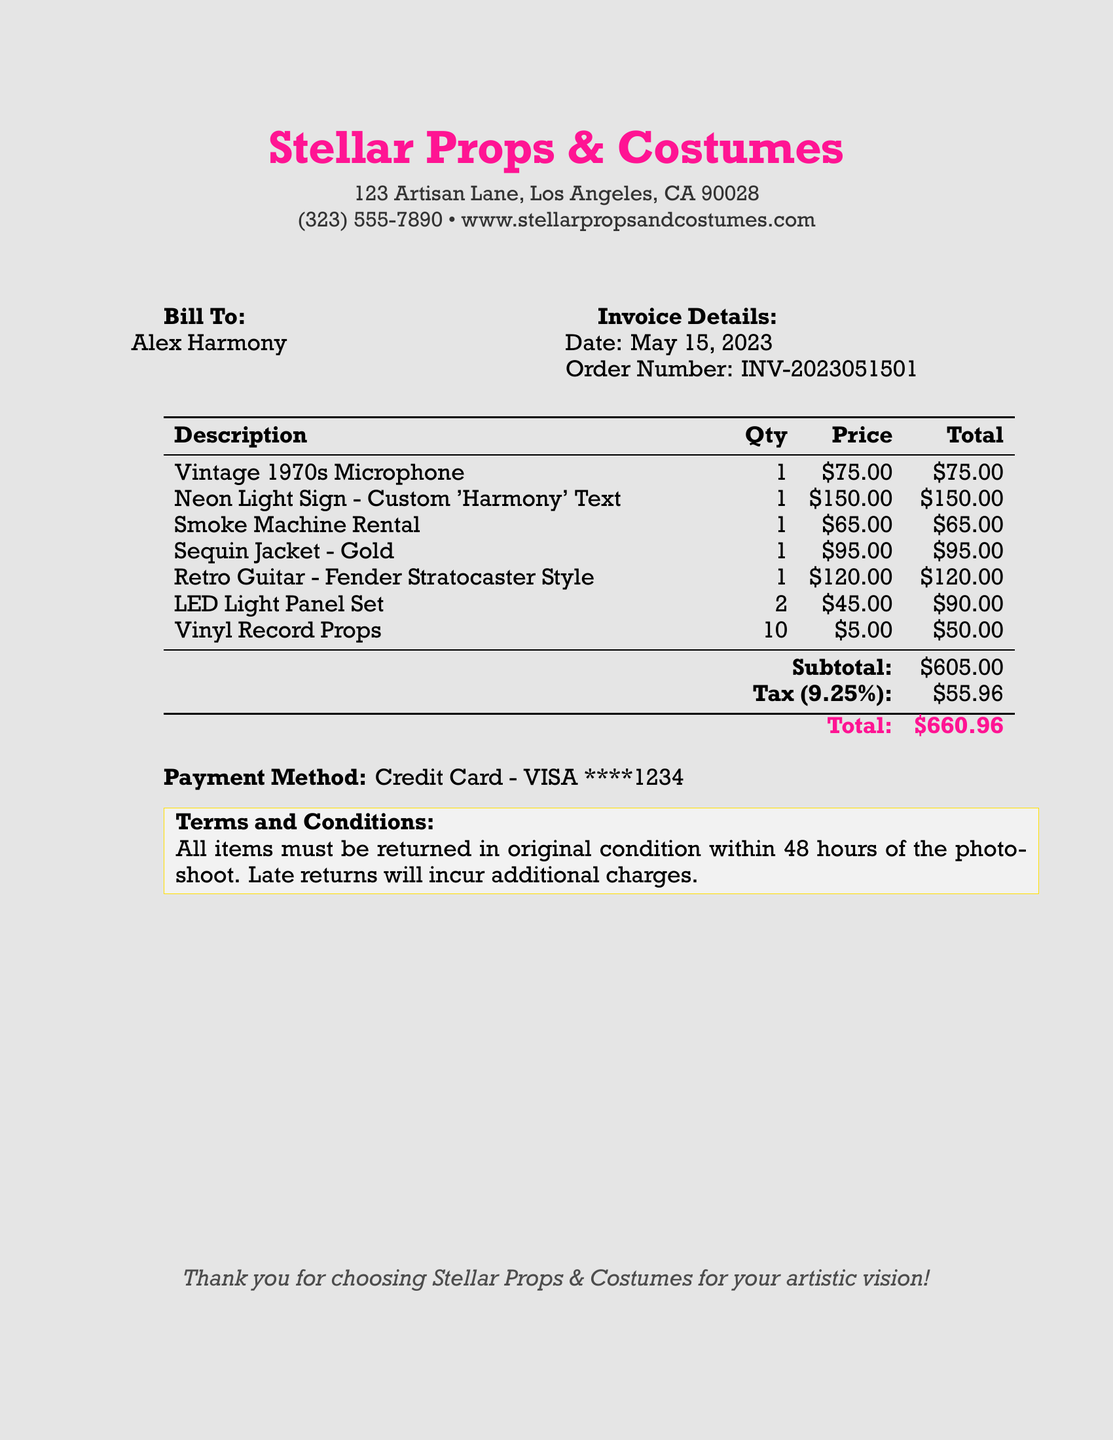What is the name of the rental company? The bill states the name of the rental company as "Stellar Props & Costumes."
Answer: Stellar Props & Costumes What is the order number? The document lists the order number as "INV-2023051501."
Answer: INV-2023051501 What is the invoice date? The invoice date is provided as "May 15, 2023."
Answer: May 15, 2023 How many LED light panels were rented? The invoice shows that 2 LED light panels were rented.
Answer: 2 What is the subtotal amount? The subtotal amount shown in the invoice is "$605.00."
Answer: $605.00 What percentage is the tax applied? The document states that the tax rate is "9.25%."
Answer: 9.25% What is the payment method? The payment method on the invoice is "Credit Card - VISA."
Answer: Credit Card - VISA What is the total amount due? The total amount due listed in the document is "$660.96."
Answer: $660.96 What is the return condition specified? The terms indicate that "All items must be returned in original condition within 48 hours of the photoshoot."
Answer: All items must be returned in original condition within 48 hours 